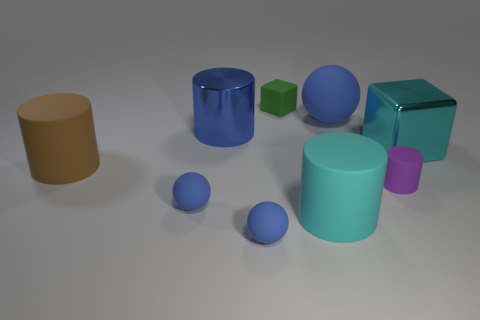Is the material of the ball behind the large cyan block the same as the big cyan cube?
Offer a terse response. No. How many other objects are there of the same size as the purple cylinder?
Your answer should be compact. 3. What number of tiny objects are either blue things or cyan matte blocks?
Your answer should be compact. 2. Do the metallic block and the big sphere have the same color?
Offer a very short reply. No. Are there more cyan rubber objects behind the shiny cylinder than brown objects that are in front of the brown matte thing?
Provide a short and direct response. No. There is a matte sphere that is right of the tiny cube; is it the same color as the big metal cylinder?
Your answer should be very brief. Yes. Is there any other thing that is the same color as the small rubber block?
Your answer should be very brief. No. Is the number of metal things that are in front of the blue shiny cylinder greater than the number of brown metal things?
Provide a short and direct response. Yes. Is the size of the purple cylinder the same as the blue metal object?
Provide a short and direct response. No. There is a brown object that is the same shape as the purple thing; what is it made of?
Offer a terse response. Rubber. 